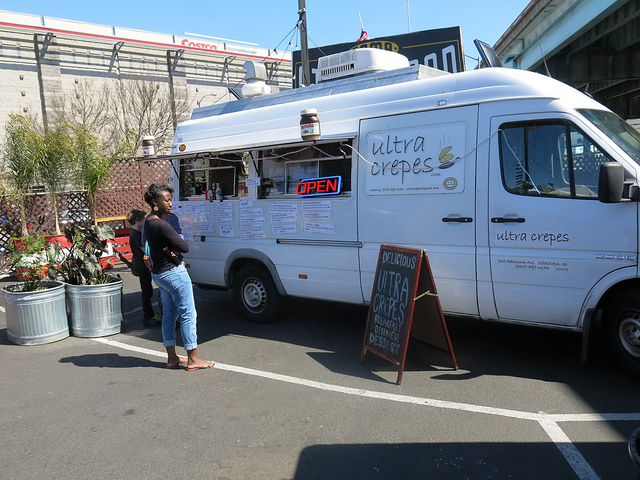What kind of food does the truck sell? Based on the signage, the truck specializes in crepes, offering a variety of delicious options likely to cater to both sweet and savory preferences. 